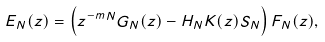<formula> <loc_0><loc_0><loc_500><loc_500>E _ { N } ( z ) = \left ( z ^ { - m N } G _ { N } ( z ) - H _ { N } K ( z ) S _ { N } \right ) F _ { N } ( z ) ,</formula> 